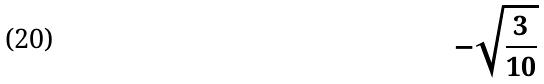<formula> <loc_0><loc_0><loc_500><loc_500>- \sqrt { \frac { 3 } { 1 0 } }</formula> 